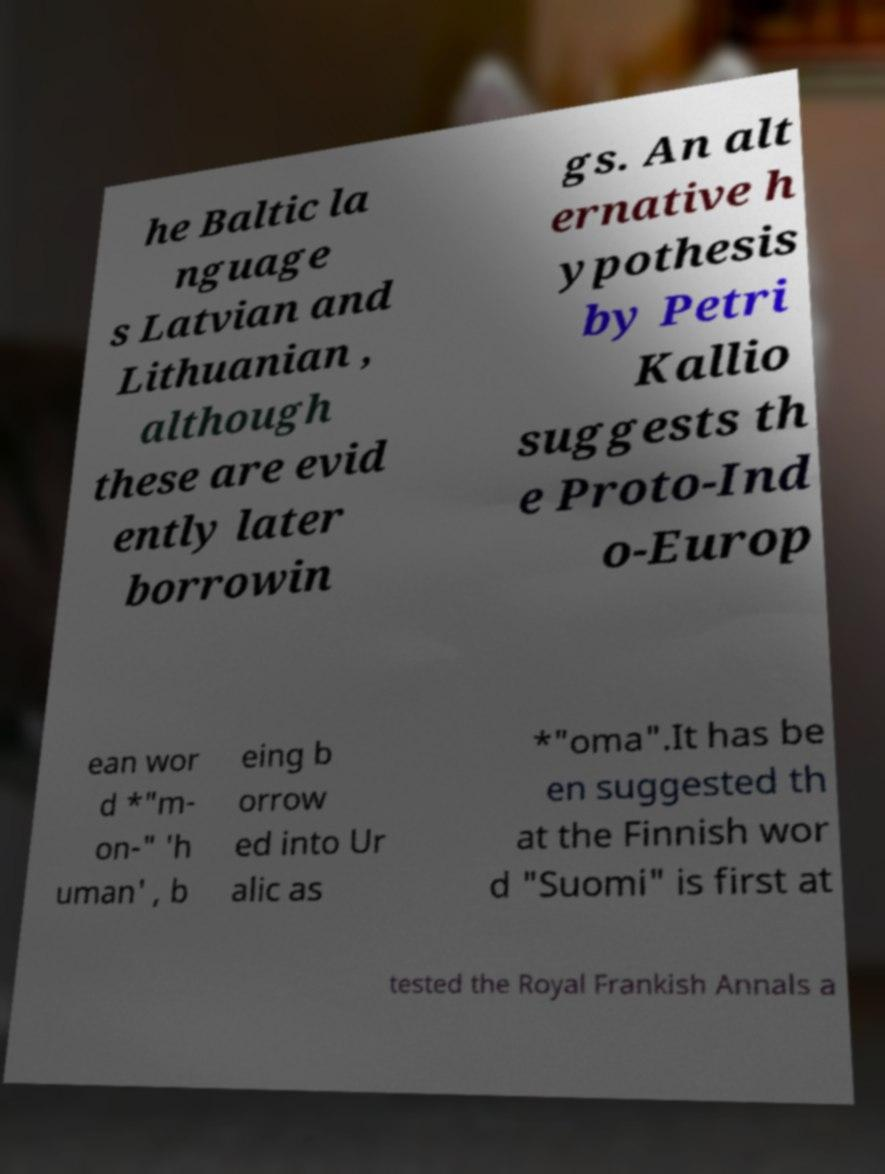Please read and relay the text visible in this image. What does it say? he Baltic la nguage s Latvian and Lithuanian , although these are evid ently later borrowin gs. An alt ernative h ypothesis by Petri Kallio suggests th e Proto-Ind o-Europ ean wor d *"m- on-" 'h uman' , b eing b orrow ed into Ur alic as *"oma".It has be en suggested th at the Finnish wor d "Suomi" is first at tested the Royal Frankish Annals a 